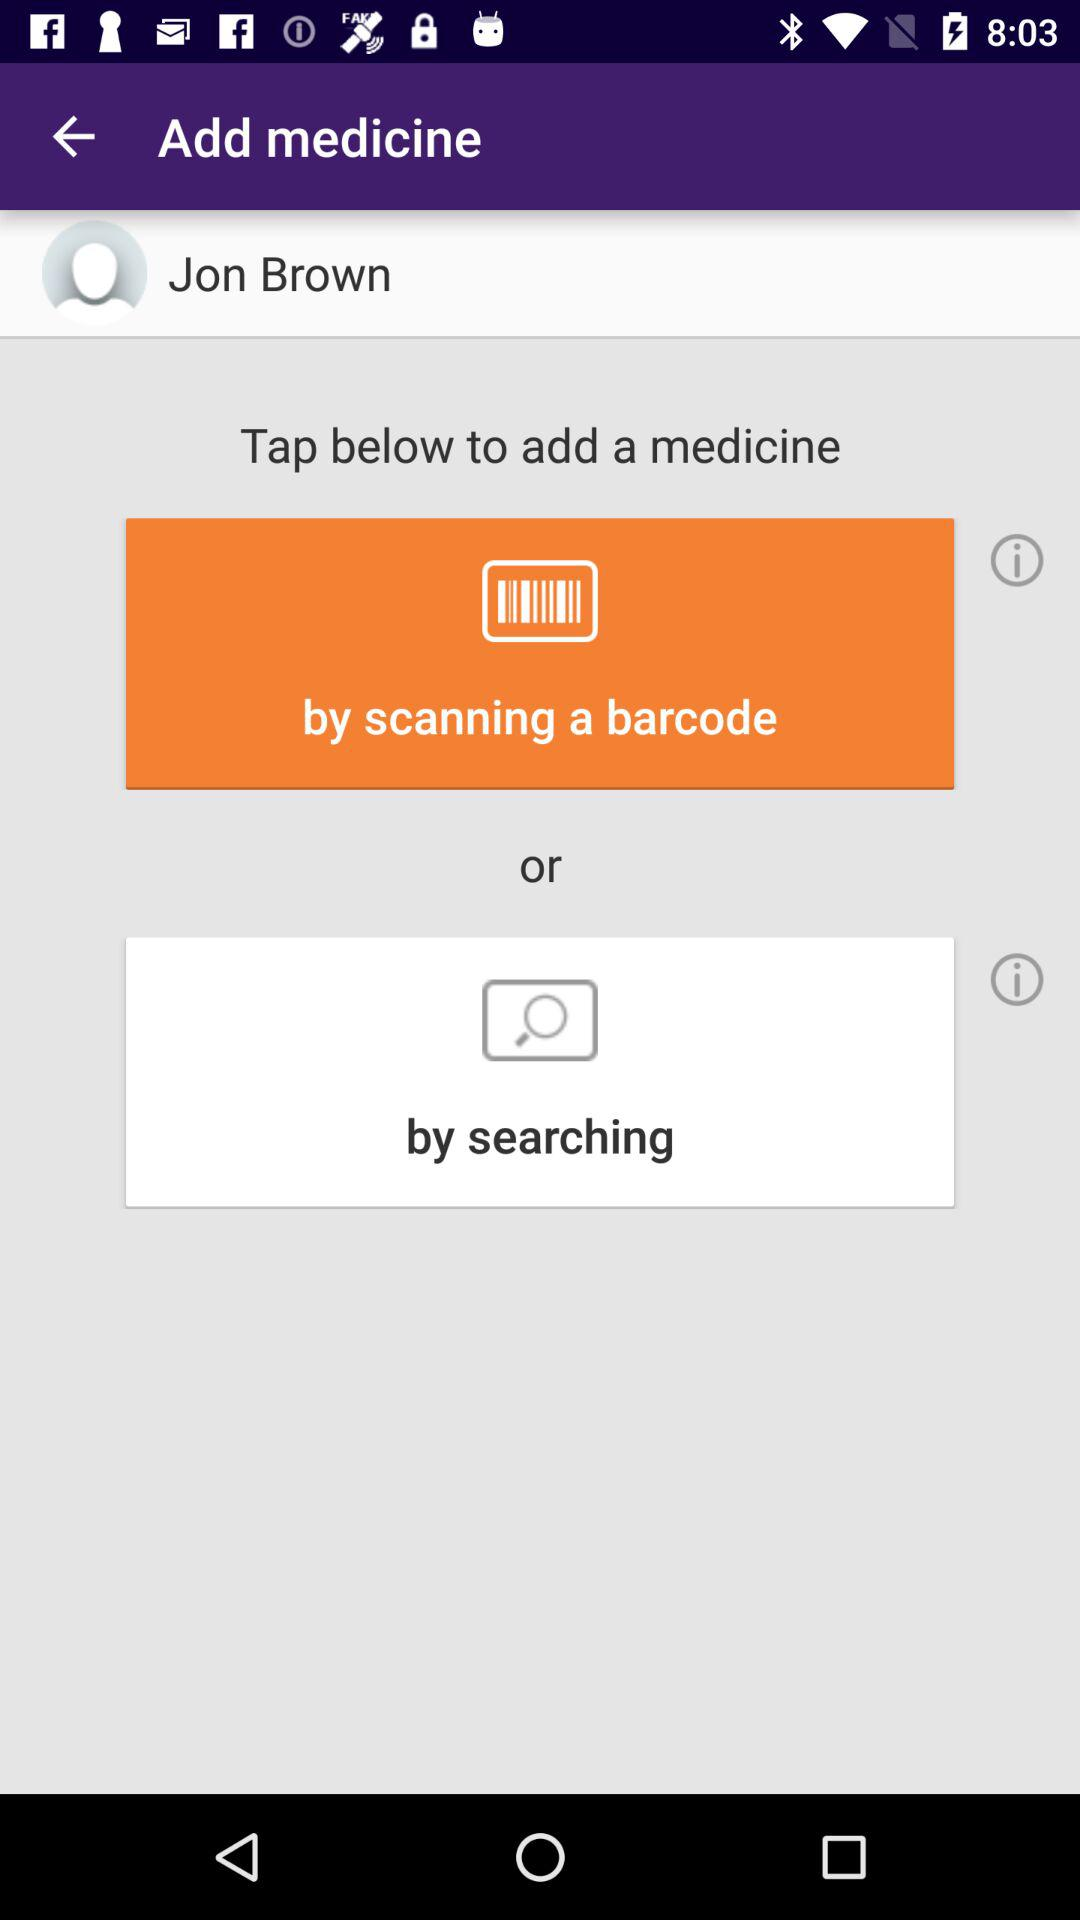How many ways are there to add a medicine?
Answer the question using a single word or phrase. 2 